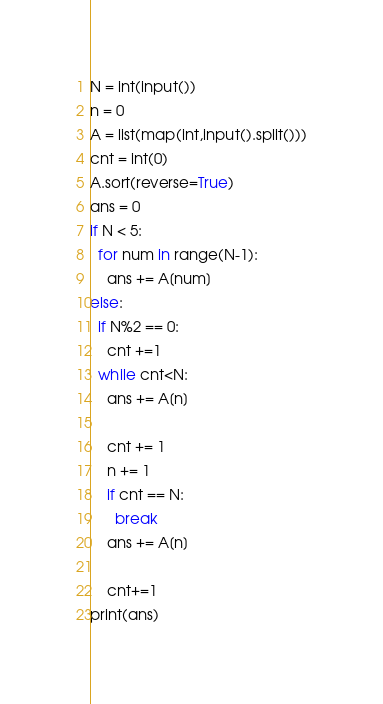Convert code to text. <code><loc_0><loc_0><loc_500><loc_500><_Python_>N = int(input())
n = 0
A = list(map(int,input().split()))
cnt = int(0)
A.sort(reverse=True)
ans = 0
if N < 5:
  for num in range(N-1):
    ans += A[num]
else:
  if N%2 == 0:
    cnt +=1
  while cnt<N:
    ans += A[n]
    
    cnt += 1
    n += 1
    if cnt == N:
      break
    ans += A[n]
    
    cnt+=1
print(ans)</code> 